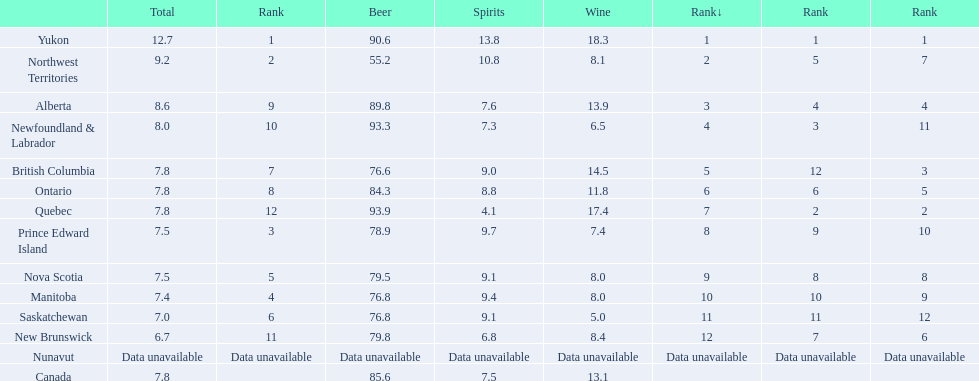Where do people consume the highest average of spirits per year? Yukon. How many liters on average do people here drink per year of spirits? 12.7. 